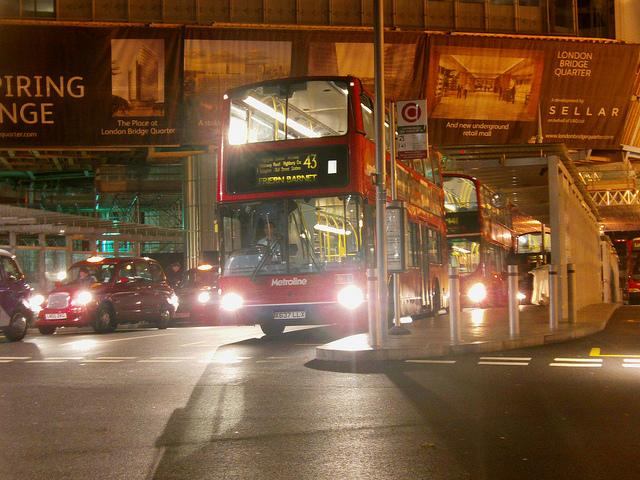What country is it? england 